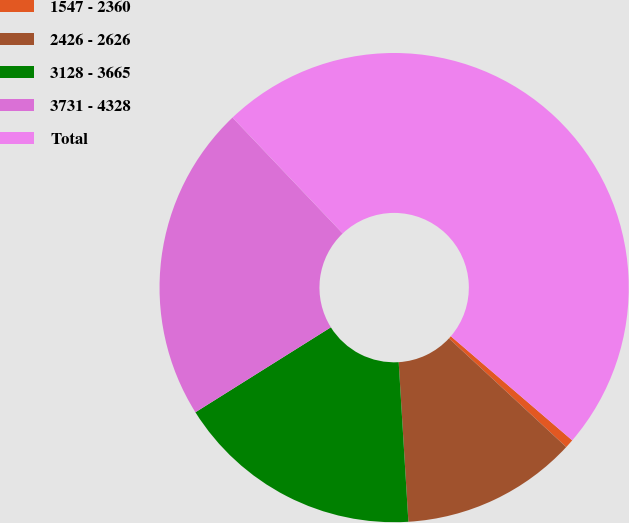Convert chart. <chart><loc_0><loc_0><loc_500><loc_500><pie_chart><fcel>1547 - 2360<fcel>2426 - 2626<fcel>3128 - 3665<fcel>3731 - 4328<fcel>Total<nl><fcel>0.61%<fcel>12.14%<fcel>17.05%<fcel>21.82%<fcel>48.38%<nl></chart> 